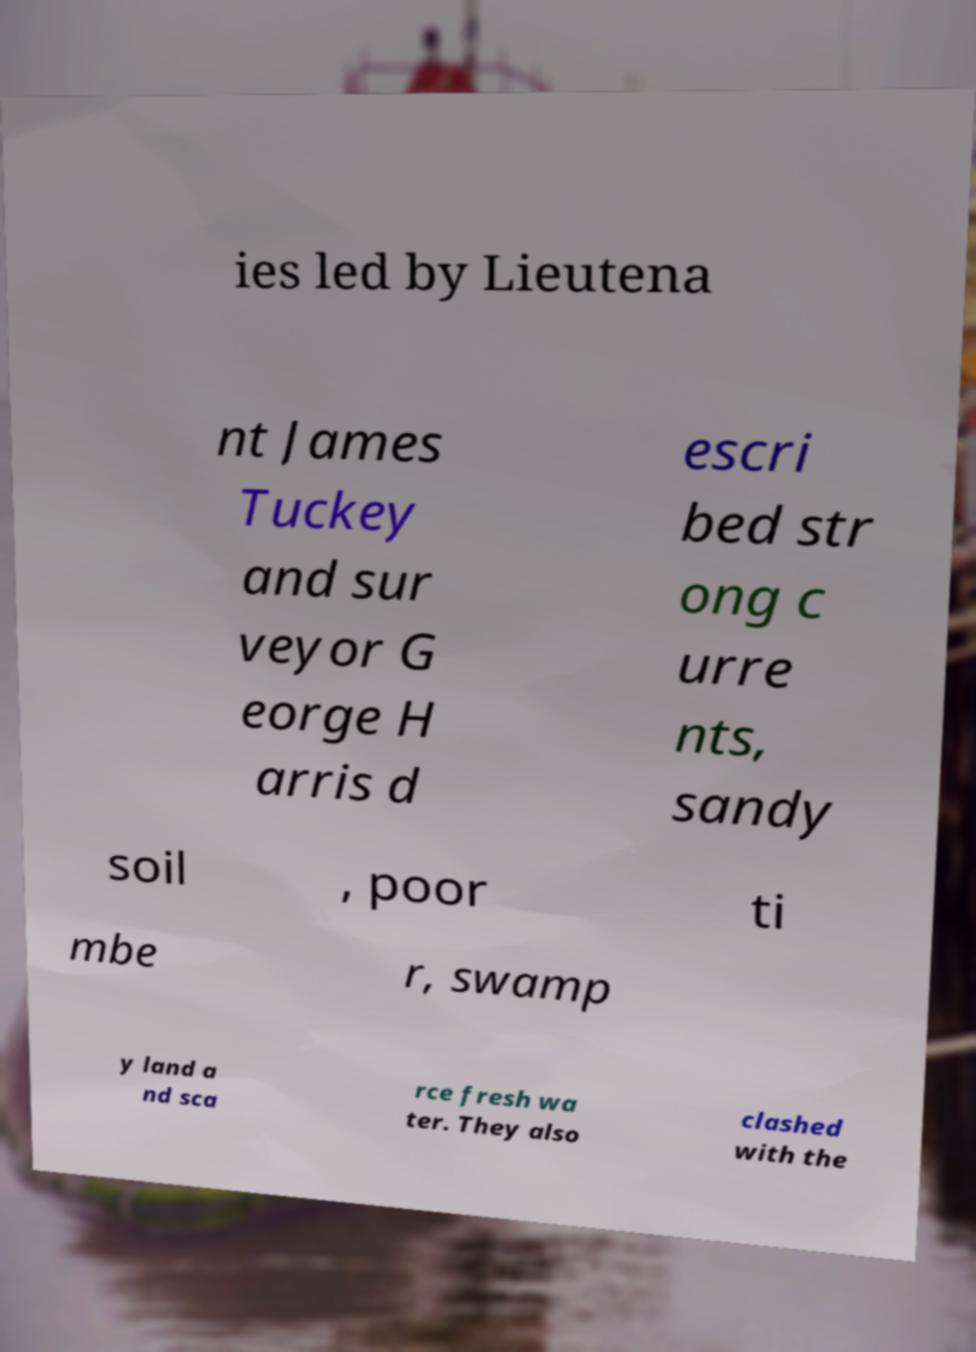For documentation purposes, I need the text within this image transcribed. Could you provide that? ies led by Lieutena nt James Tuckey and sur veyor G eorge H arris d escri bed str ong c urre nts, sandy soil , poor ti mbe r, swamp y land a nd sca rce fresh wa ter. They also clashed with the 